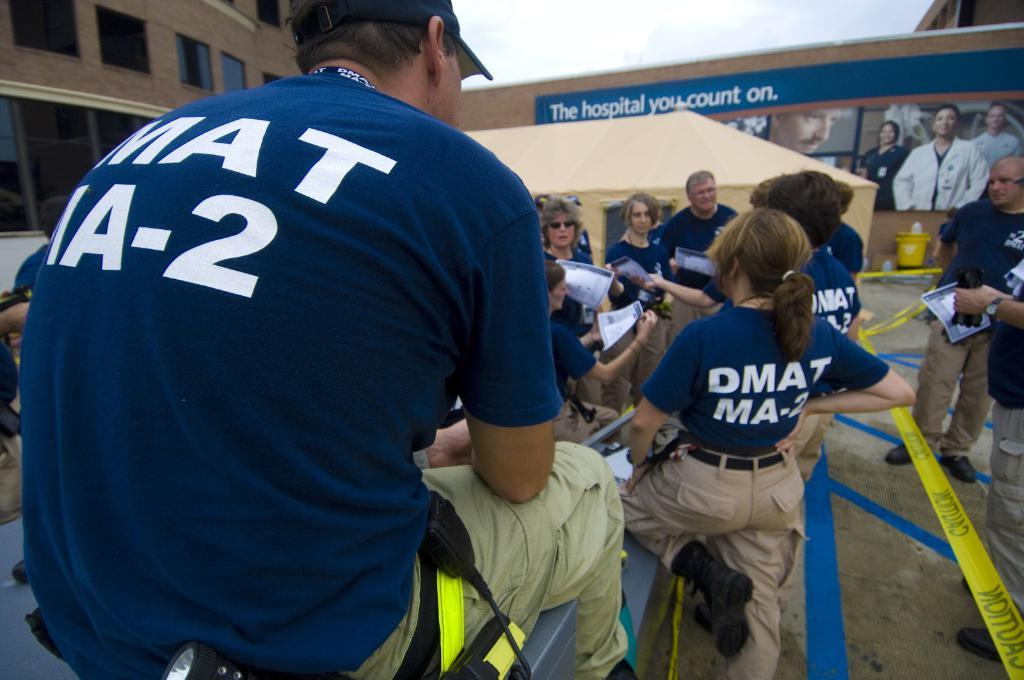<image>
Create a compact narrative representing the image presented. A group of people talk and socialize in front of a large outdoor advertisement which reads "The hospital you count on". 